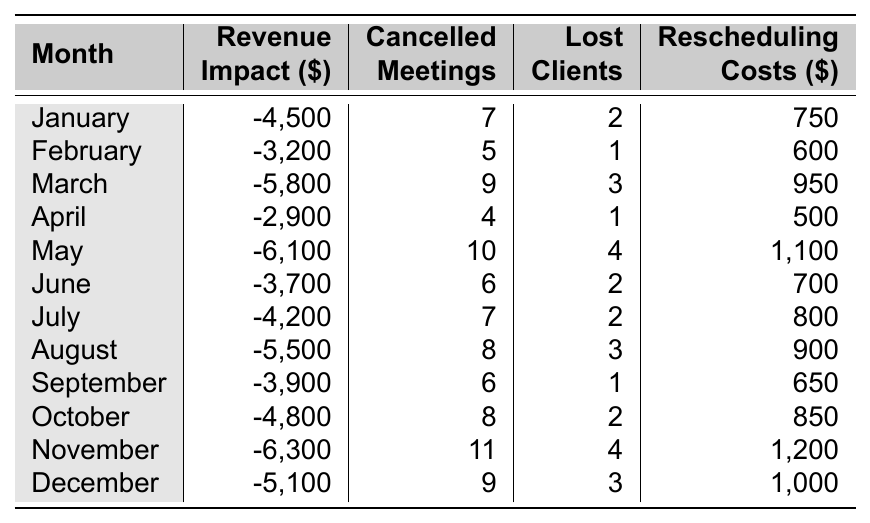What was the revenue impact in November? The table shows that the revenue impact in November is listed as -6,300 dollars.
Answer: -6,300 How many meetings were cancelled in March? The table indicates that in March, there were 9 cancelled meetings.
Answer: 9 What is the total revenue impact from January to March? To find it, add the revenue impacts for January (-4,500), February (-3,200), and March (-5,800): -4,500 + (-3,200) + (-5,800) = -13,500.
Answer: -13,500 Which month had the highest number of cancelled meetings? Looking at the cancelled meetings column, November has the highest value with 11 cancelled meetings.
Answer: November Was the revenue impact in May worse than in April? The revenue impact in May is -6,100 and in April it is -2,900. Since -6,100 is less than -2,900, the impact in May is worse.
Answer: Yes Calculate the average rescheduling cost for the year. Add all the rescheduling costs: (750 + 600 + 950 + 500 + 1100 + 700 + 800 + 900 + 650 + 850 + 1200 + 1000) = 10,100. There are 12 months, so the average is 10,100 / 12 = 841.67.
Answer: 841.67 Which month had the least revenue impact? Examining the revenue impact, April has the least negative value at -2,900.
Answer: April Is it true that the number of lost clients in June was fewer than in May? In June, there were 2 lost clients, while in May there were 4. Therefore, it is true that June had fewer lost clients than May.
Answer: Yes What is the difference in revenue impact between the best and worst months? The best month is April (-2,900) and the worst is November (-6,300). The difference is -2,900 - (-6,300) = -2,900 + 6,300 = 3,400.
Answer: 3,400 In which month did the business incur the highest rescheduling costs? The highest rescheduling cost of 1,200 dollars occurred in November, as seen in the respective column.
Answer: November 